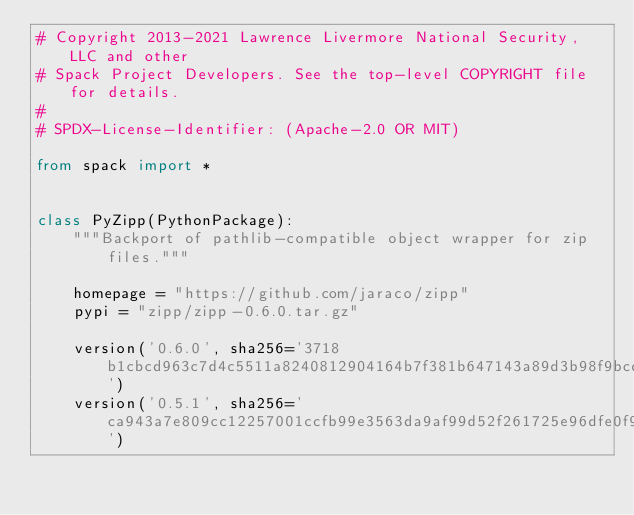<code> <loc_0><loc_0><loc_500><loc_500><_Python_># Copyright 2013-2021 Lawrence Livermore National Security, LLC and other
# Spack Project Developers. See the top-level COPYRIGHT file for details.
#
# SPDX-License-Identifier: (Apache-2.0 OR MIT)

from spack import *


class PyZipp(PythonPackage):
    """Backport of pathlib-compatible object wrapper for zip files."""

    homepage = "https://github.com/jaraco/zipp"
    pypi = "zipp/zipp-0.6.0.tar.gz"

    version('0.6.0', sha256='3718b1cbcd963c7d4c5511a8240812904164b7f381b647143a89d3b98f9bcd8e')
    version('0.5.1', sha256='ca943a7e809cc12257001ccfb99e3563da9af99d52f261725e96dfe0f9275bc3')
</code> 